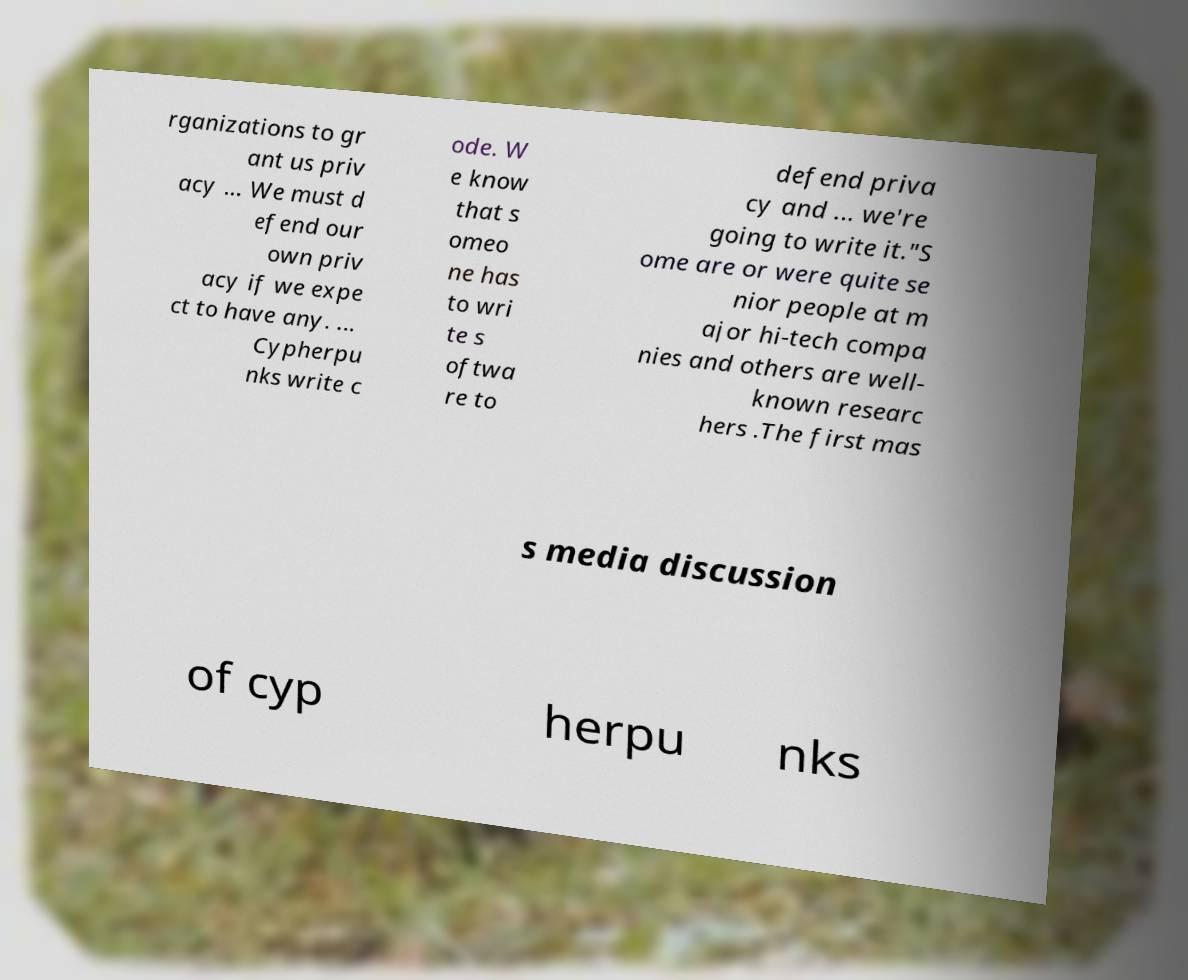Can you accurately transcribe the text from the provided image for me? rganizations to gr ant us priv acy ... We must d efend our own priv acy if we expe ct to have any. ... Cypherpu nks write c ode. W e know that s omeo ne has to wri te s oftwa re to defend priva cy and ... we're going to write it."S ome are or were quite se nior people at m ajor hi-tech compa nies and others are well- known researc hers .The first mas s media discussion of cyp herpu nks 